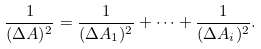Convert formula to latex. <formula><loc_0><loc_0><loc_500><loc_500>\frac { 1 } { ( \Delta A ) ^ { 2 } } = \frac { 1 } { ( \Delta A _ { 1 } ) ^ { 2 } } + \dots + \frac { 1 } { ( \Delta A _ { i } ) ^ { 2 } } .</formula> 